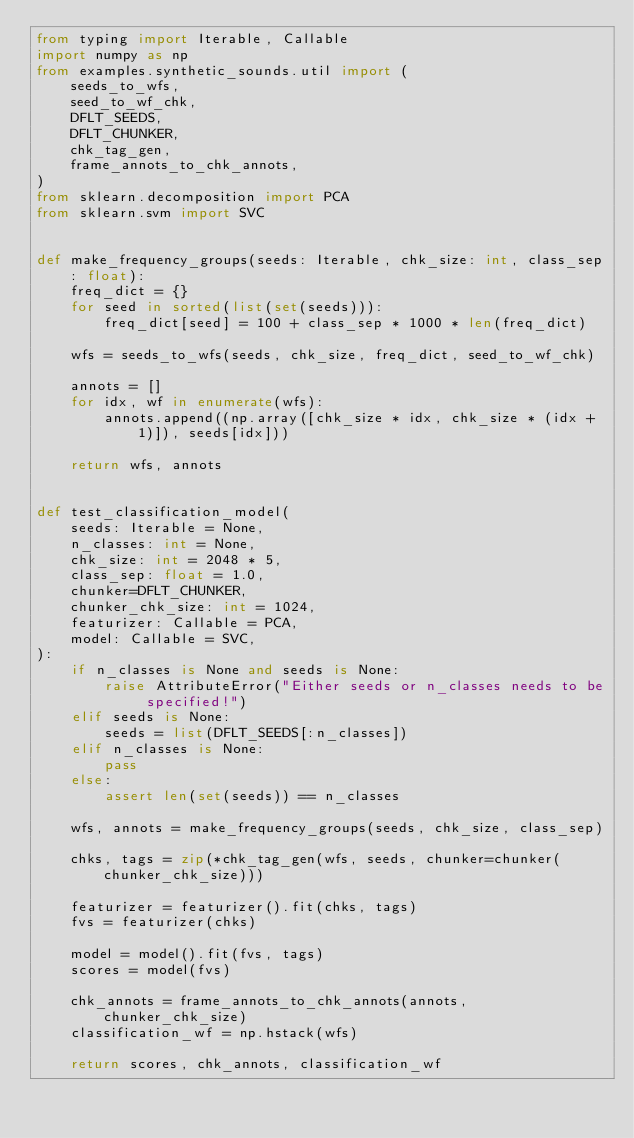<code> <loc_0><loc_0><loc_500><loc_500><_Python_>from typing import Iterable, Callable
import numpy as np
from examples.synthetic_sounds.util import (
    seeds_to_wfs,
    seed_to_wf_chk,
    DFLT_SEEDS,
    DFLT_CHUNKER,
    chk_tag_gen,
    frame_annots_to_chk_annots,
)
from sklearn.decomposition import PCA
from sklearn.svm import SVC


def make_frequency_groups(seeds: Iterable, chk_size: int, class_sep: float):
    freq_dict = {}
    for seed in sorted(list(set(seeds))):
        freq_dict[seed] = 100 + class_sep * 1000 * len(freq_dict)

    wfs = seeds_to_wfs(seeds, chk_size, freq_dict, seed_to_wf_chk)

    annots = []
    for idx, wf in enumerate(wfs):
        annots.append((np.array([chk_size * idx, chk_size * (idx + 1)]), seeds[idx]))

    return wfs, annots


def test_classification_model(
    seeds: Iterable = None,
    n_classes: int = None,
    chk_size: int = 2048 * 5,
    class_sep: float = 1.0,
    chunker=DFLT_CHUNKER,
    chunker_chk_size: int = 1024,
    featurizer: Callable = PCA,
    model: Callable = SVC,
):
    if n_classes is None and seeds is None:
        raise AttributeError("Either seeds or n_classes needs to be specified!")
    elif seeds is None:
        seeds = list(DFLT_SEEDS[:n_classes])
    elif n_classes is None:
        pass
    else:
        assert len(set(seeds)) == n_classes

    wfs, annots = make_frequency_groups(seeds, chk_size, class_sep)

    chks, tags = zip(*chk_tag_gen(wfs, seeds, chunker=chunker(chunker_chk_size)))

    featurizer = featurizer().fit(chks, tags)
    fvs = featurizer(chks)

    model = model().fit(fvs, tags)
    scores = model(fvs)

    chk_annots = frame_annots_to_chk_annots(annots, chunker_chk_size)
    classification_wf = np.hstack(wfs)

    return scores, chk_annots, classification_wf
</code> 